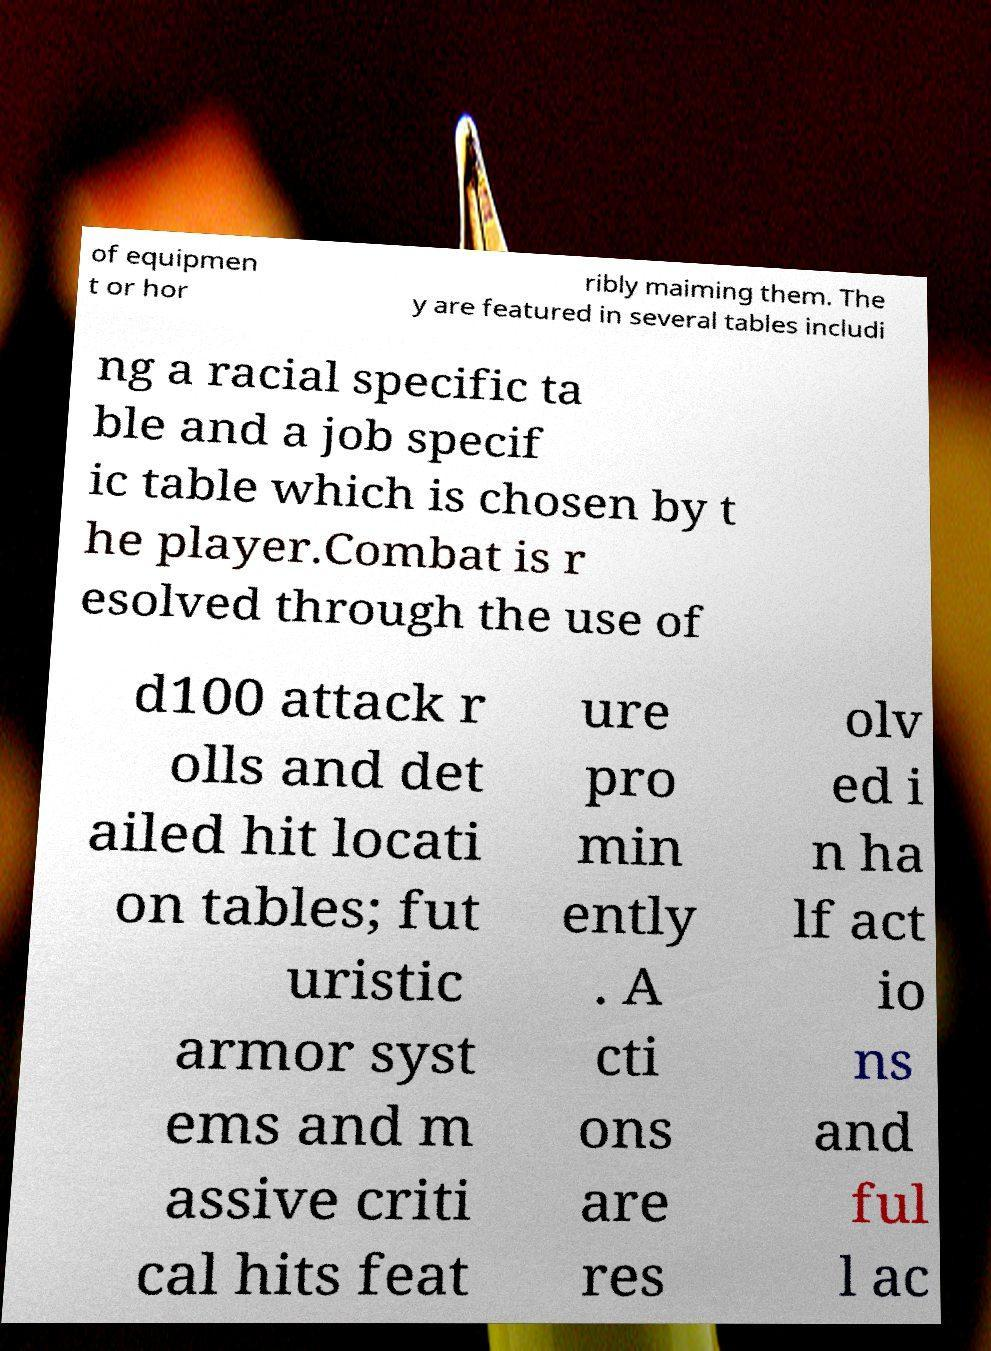What messages or text are displayed in this image? I need them in a readable, typed format. of equipmen t or hor ribly maiming them. The y are featured in several tables includi ng a racial specific ta ble and a job specif ic table which is chosen by t he player.Combat is r esolved through the use of d100 attack r olls and det ailed hit locati on tables; fut uristic armor syst ems and m assive criti cal hits feat ure pro min ently . A cti ons are res olv ed i n ha lf act io ns and ful l ac 